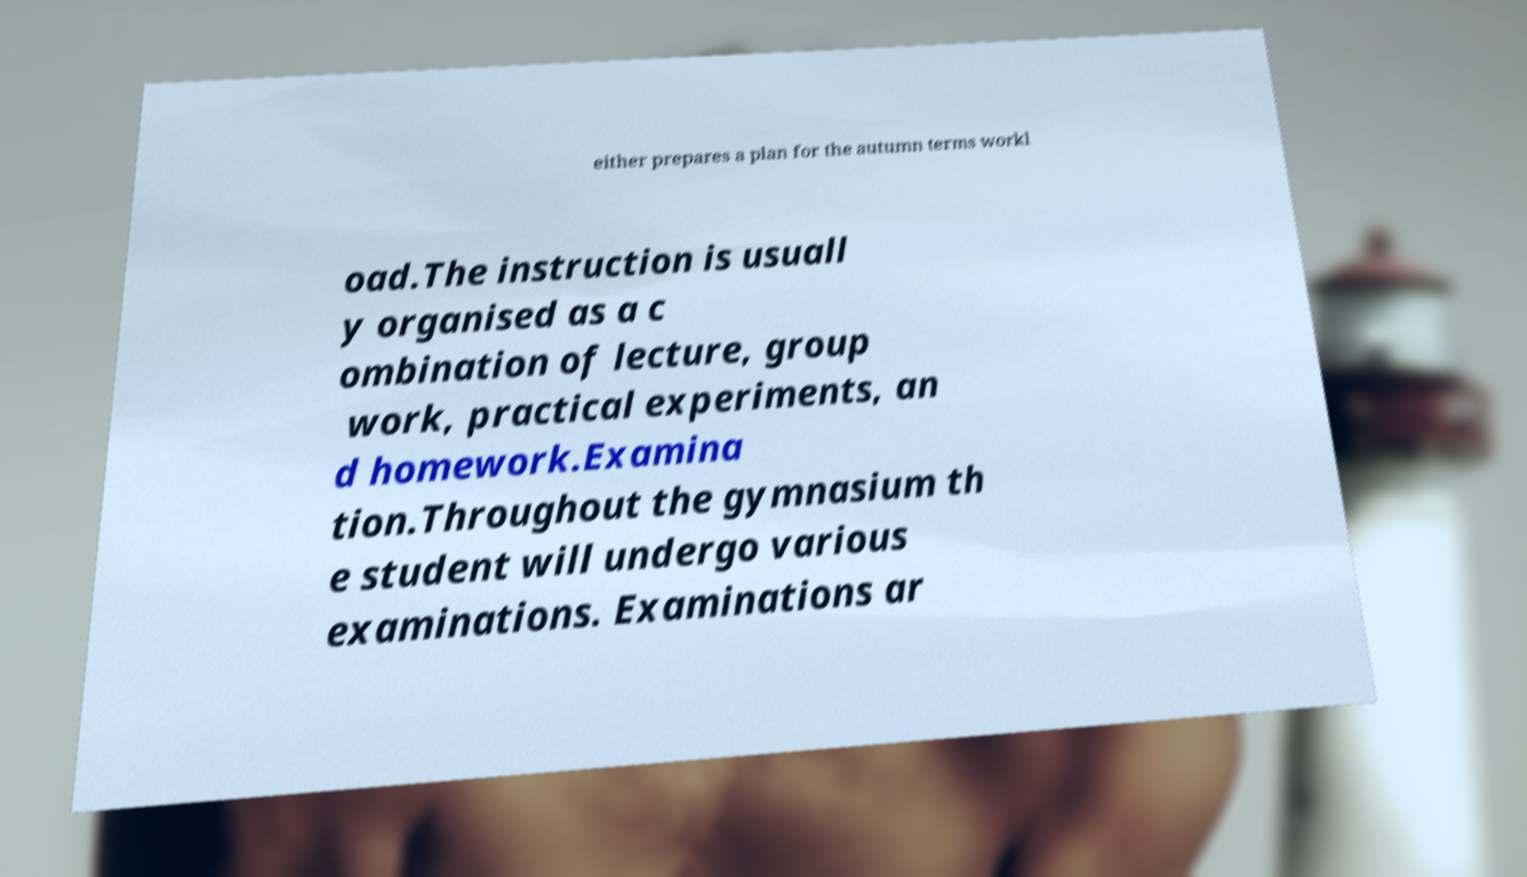I need the written content from this picture converted into text. Can you do that? either prepares a plan for the autumn terms workl oad.The instruction is usuall y organised as a c ombination of lecture, group work, practical experiments, an d homework.Examina tion.Throughout the gymnasium th e student will undergo various examinations. Examinations ar 